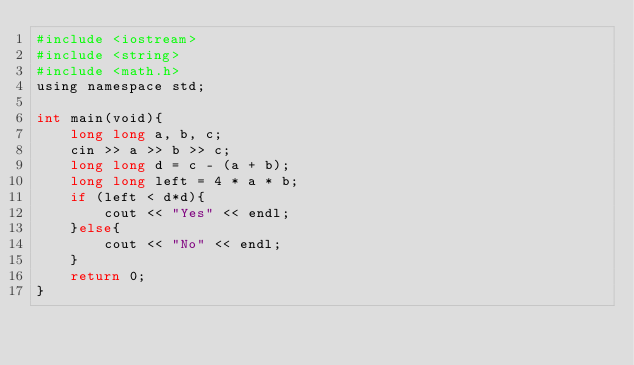<code> <loc_0><loc_0><loc_500><loc_500><_Python_>#include <iostream>
#include <string>
#include <math.h>
using namespace std;

int main(void){
    long long a, b, c;
    cin >> a >> b >> c;
    long long d = c - (a + b);
    long long left = 4 * a * b;
    if (left < d*d){
        cout << "Yes" << endl;
    }else{
        cout << "No" << endl;
    }
    return 0;
}</code> 